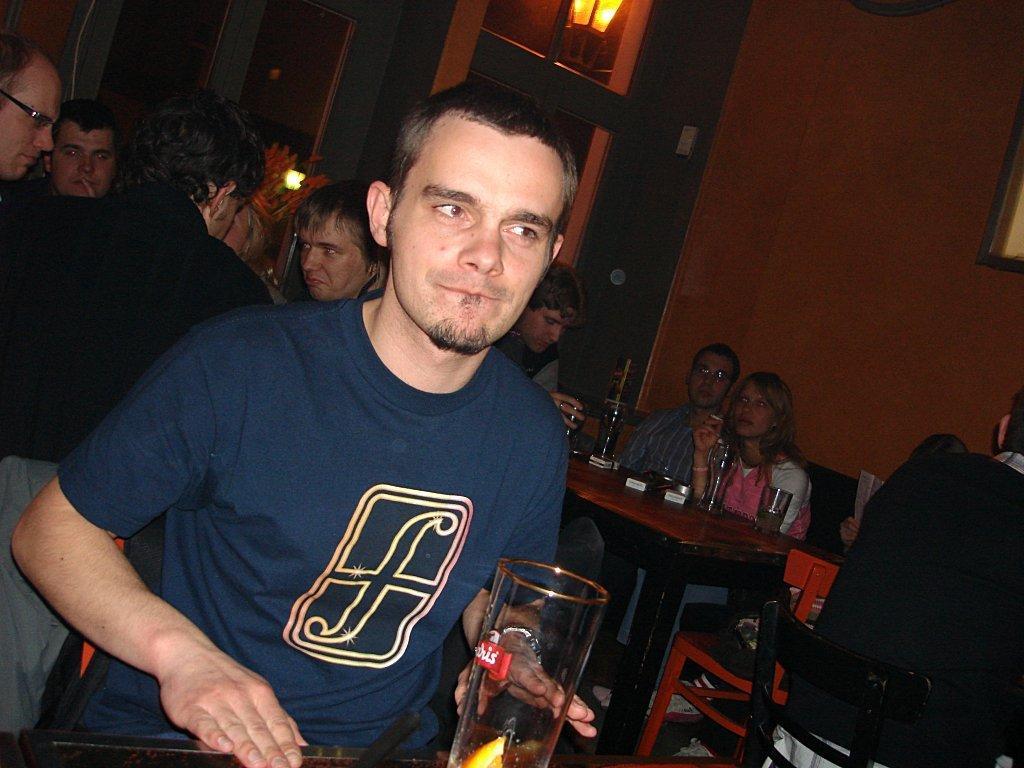Could you give a brief overview of what you see in this image? In this image I can see a group of people are sitting on the chairs in front of tables on which I can see liquor bottles and glasses and a few of them are holding glasses in their hand. In the background, I can see walls, lights and doors. This image is taken may be in a restaurant. 